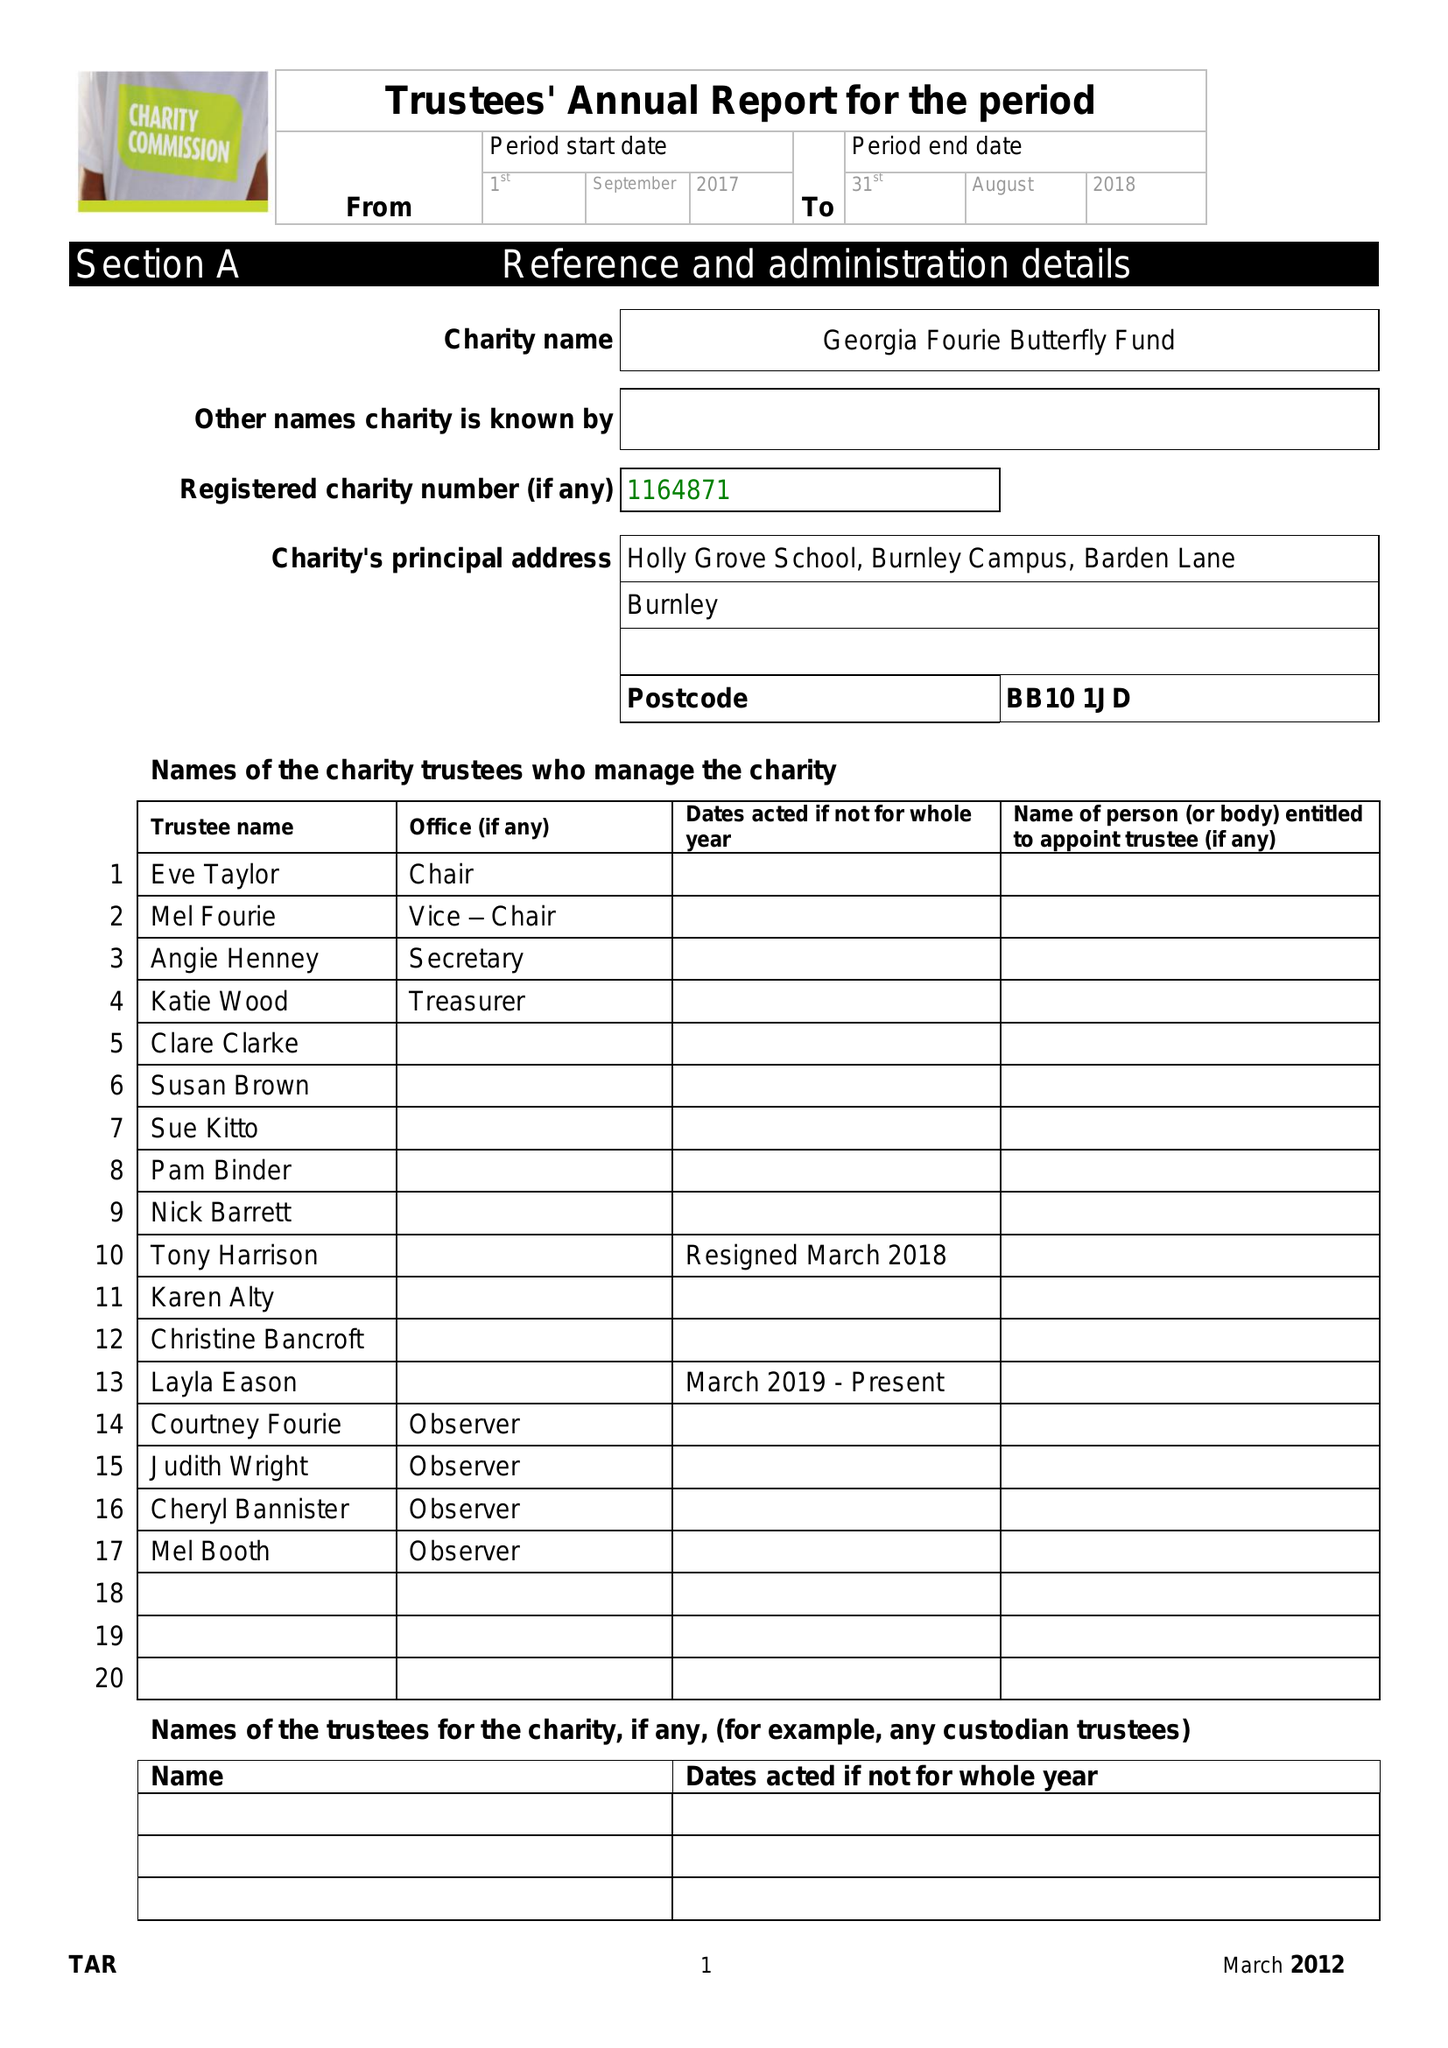What is the value for the spending_annually_in_british_pounds?
Answer the question using a single word or phrase. 33881.00 